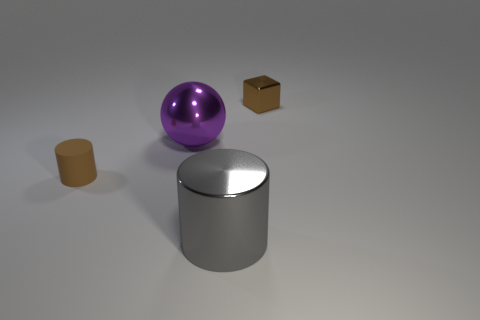Add 2 small yellow metal balls. How many objects exist? 6 Subtract all spheres. How many objects are left? 3 Subtract 1 balls. How many balls are left? 0 Subtract all yellow balls. Subtract all blue cylinders. How many balls are left? 1 Subtract all small green rubber balls. Subtract all big metal cylinders. How many objects are left? 3 Add 2 matte cylinders. How many matte cylinders are left? 3 Add 2 large gray metal objects. How many large gray metal objects exist? 3 Subtract 0 red cylinders. How many objects are left? 4 